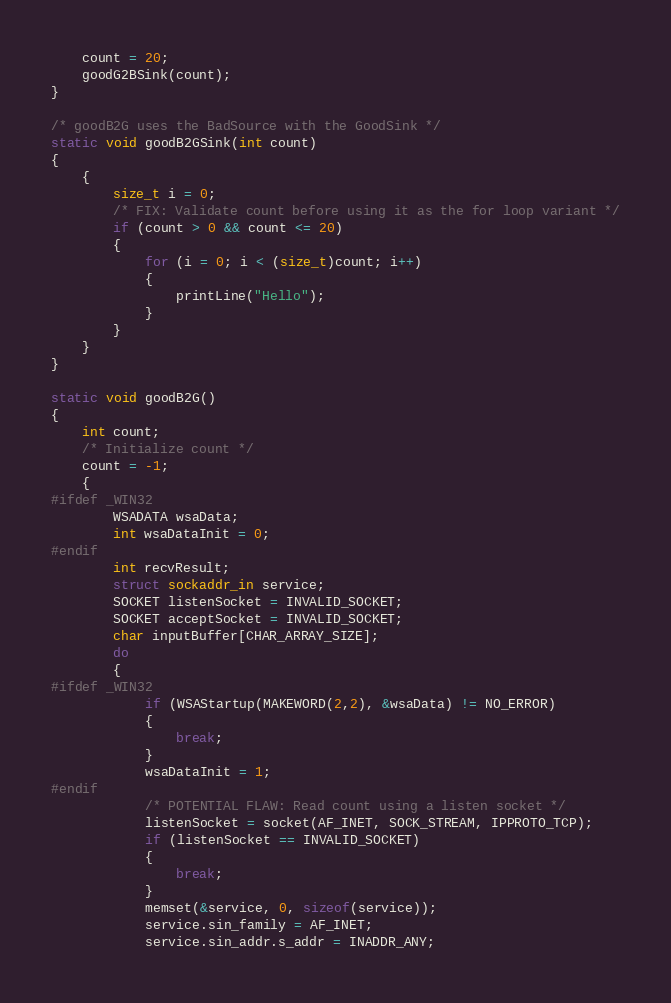Convert code to text. <code><loc_0><loc_0><loc_500><loc_500><_C_>    count = 20;
    goodG2BSink(count);
}

/* goodB2G uses the BadSource with the GoodSink */
static void goodB2GSink(int count)
{
    {
        size_t i = 0;
        /* FIX: Validate count before using it as the for loop variant */
        if (count > 0 && count <= 20)
        {
            for (i = 0; i < (size_t)count; i++)
            {
                printLine("Hello");
            }
        }
    }
}

static void goodB2G()
{
    int count;
    /* Initialize count */
    count = -1;
    {
#ifdef _WIN32
        WSADATA wsaData;
        int wsaDataInit = 0;
#endif
        int recvResult;
        struct sockaddr_in service;
        SOCKET listenSocket = INVALID_SOCKET;
        SOCKET acceptSocket = INVALID_SOCKET;
        char inputBuffer[CHAR_ARRAY_SIZE];
        do
        {
#ifdef _WIN32
            if (WSAStartup(MAKEWORD(2,2), &wsaData) != NO_ERROR)
            {
                break;
            }
            wsaDataInit = 1;
#endif
            /* POTENTIAL FLAW: Read count using a listen socket */
            listenSocket = socket(AF_INET, SOCK_STREAM, IPPROTO_TCP);
            if (listenSocket == INVALID_SOCKET)
            {
                break;
            }
            memset(&service, 0, sizeof(service));
            service.sin_family = AF_INET;
            service.sin_addr.s_addr = INADDR_ANY;</code> 